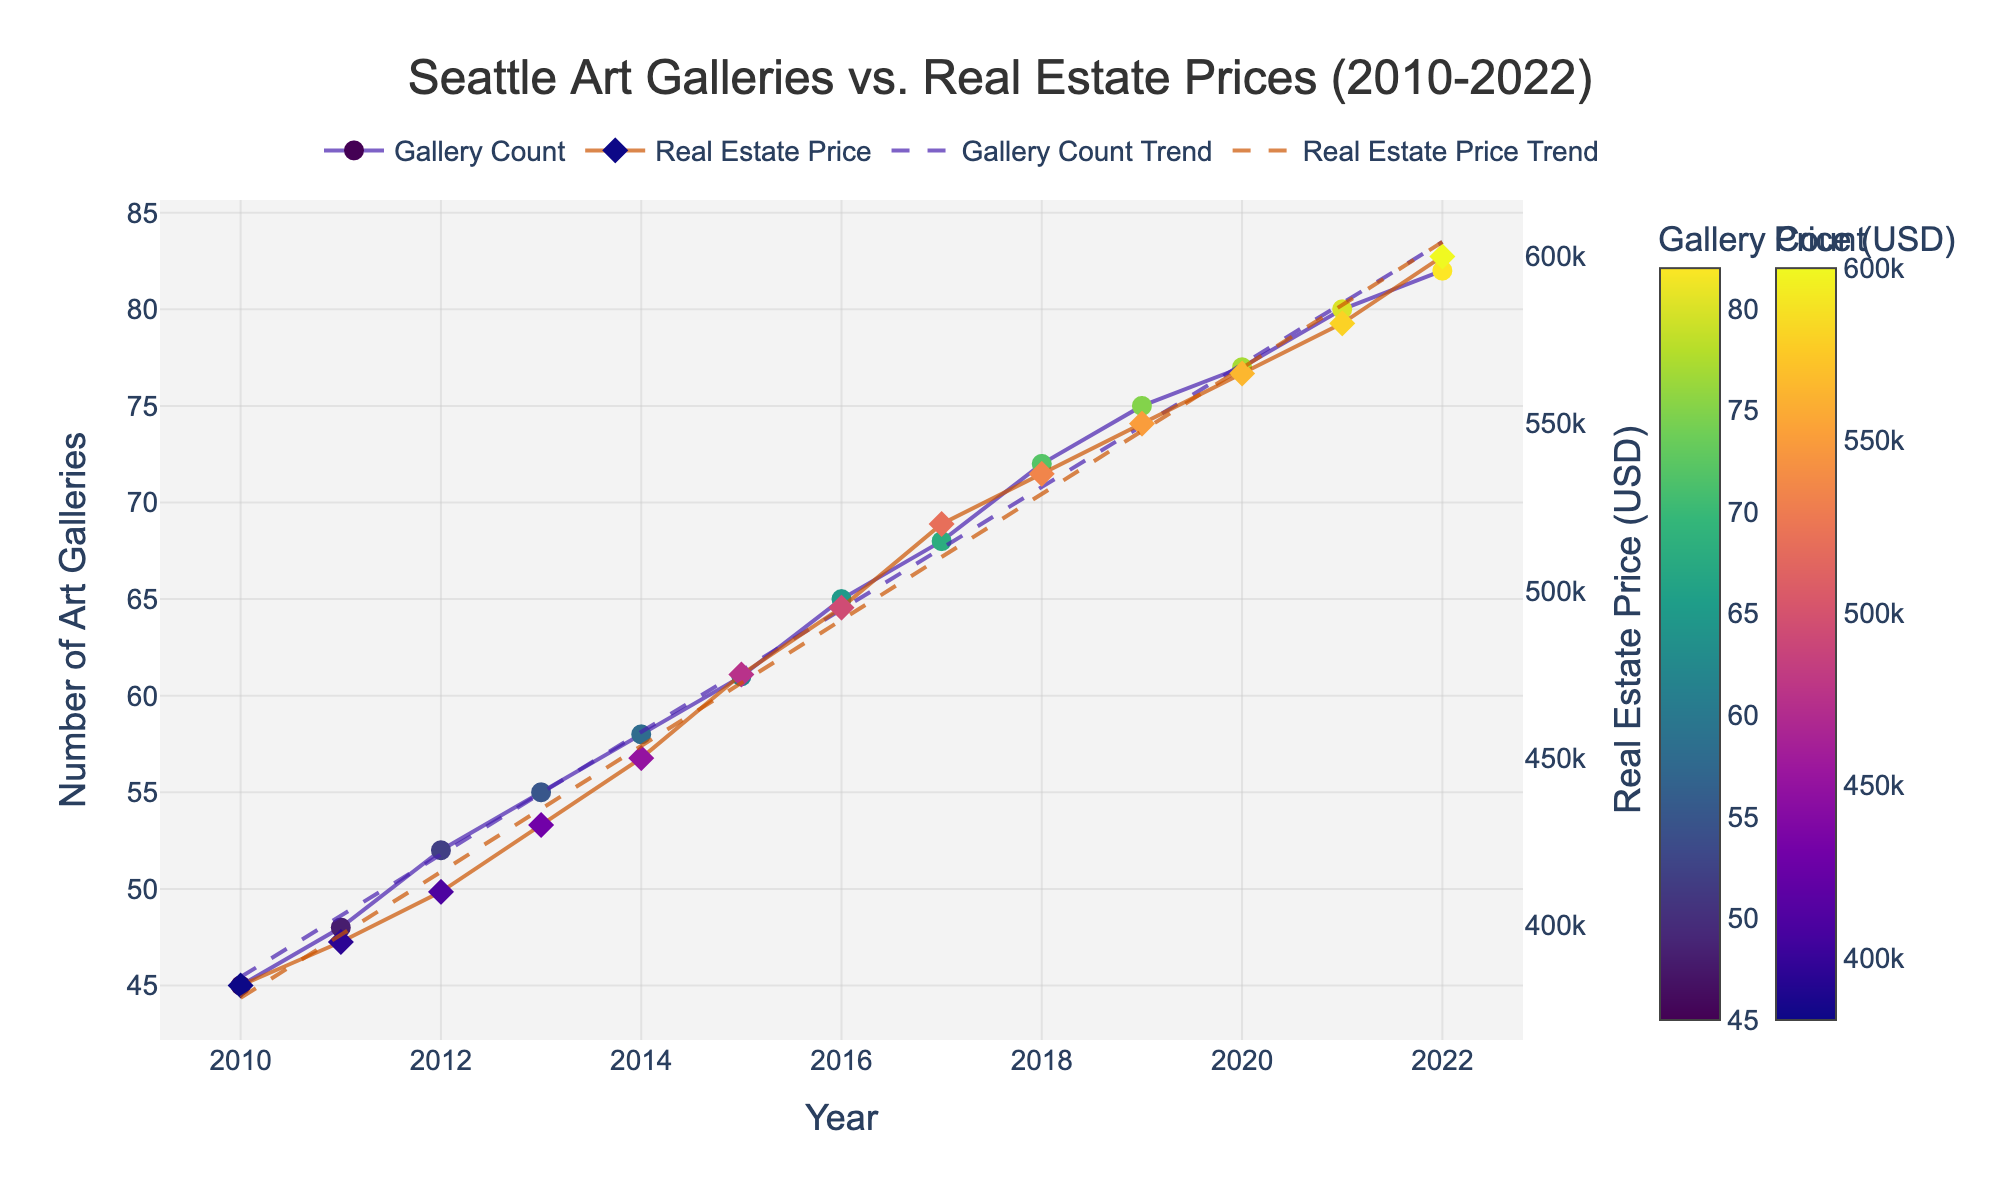What is the title of the figure? The title of the figure is displayed at the top center and provides an overview of what the figure represents. In this case, it reads "Seattle Art Galleries vs. Real Estate Prices (2010-2022)".
Answer: Seattle Art Galleries vs. Real Estate Prices (2010-2022) How many art galleries were there in Seattle in 2015? To find the number of art galleries in 2015, locate the data point on the art gallery count line. The y-axis value corresponding to 2015 is 61.
Answer: 61 What is the trend in real estate prices from 2010 to 2022? To understand the trend, observe the real estate price line and its trend line. Both show an upward trajectory from 2010 to 2022, signifying an increase.
Answer: Increasing Do art gallery counts and real estate prices show a similar trend over time? Both art gallery counts and real estate prices have trend lines that slope upwards, indicating that they both increase over time.
Answer: Yes What was the real estate price in 2022? Check the data point for real estate prices in the year 2022. The corresponding y-axis value is 600,000 USD.
Answer: 600,000 USD By how much did the number of art galleries increase from 2010 to 2022? Subtract the number of art galleries in 2010 from the number in 2022. 82 (2022) - 45 (2010) = 37.
Answer: 37 Is there a point in time where the number of art galleries appears to rise significantly compared to real estate prices? Around 2015 to 2017, the number of art galleries increases more sharply compared to the real estate prices, which increase at a steady rate.
Answer: Yes What is the real estate price range covered in the figure? Identify the minimum and maximum values on the real estate price y-axis. The range is from 382,000 USD to 600,000 USD.
Answer: 382,000 USD to 600,000 USD Which year marks the highest number of art galleries? Locate the highest point on the art gallery count line. The peak value is 82 in the year 2022.
Answer: 2022 How do the two trends correlate based on the scatter plot with trend lines? Both trends exhibit an upward movement, suggesting a positive correlation between the number of art galleries and real estate prices.
Answer: Positive correlation 